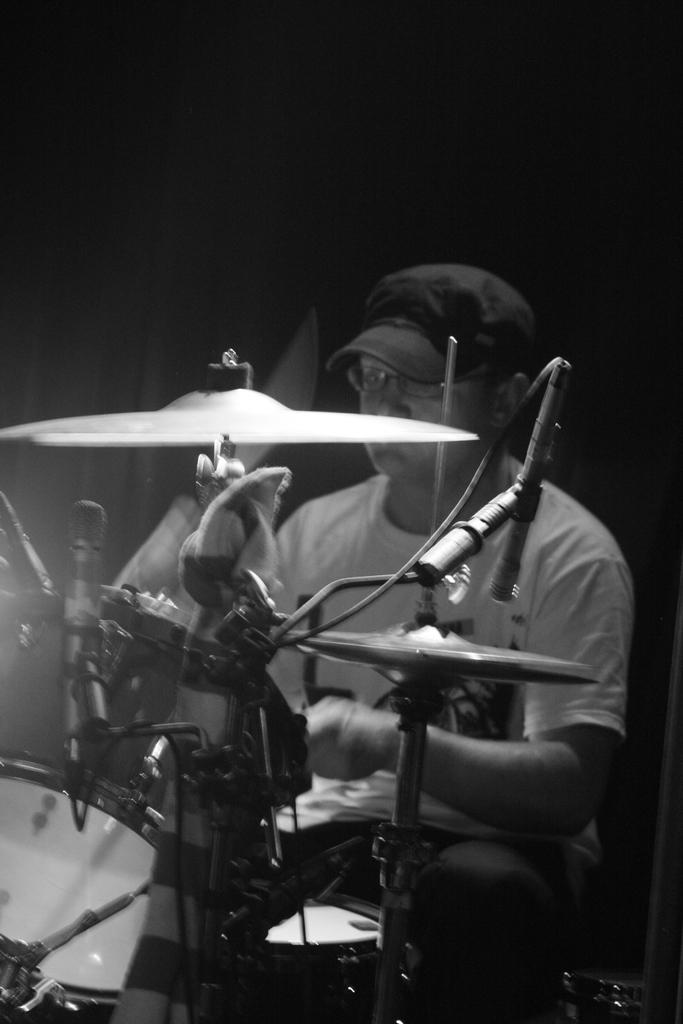Who is the main subject in the image? There is a man in the image. What is the man doing in the image? The man is playing drums. Can you describe the man's attire in the image? The man is wearing a cap. What can be observed about the lighting in the image? The background of the image is dark. What type of tools does the carpenter use in the image? There is no carpenter present in the image, and therefore no tools can be observed. How many cannons are visible in the image? There are no cannons present in the image. 